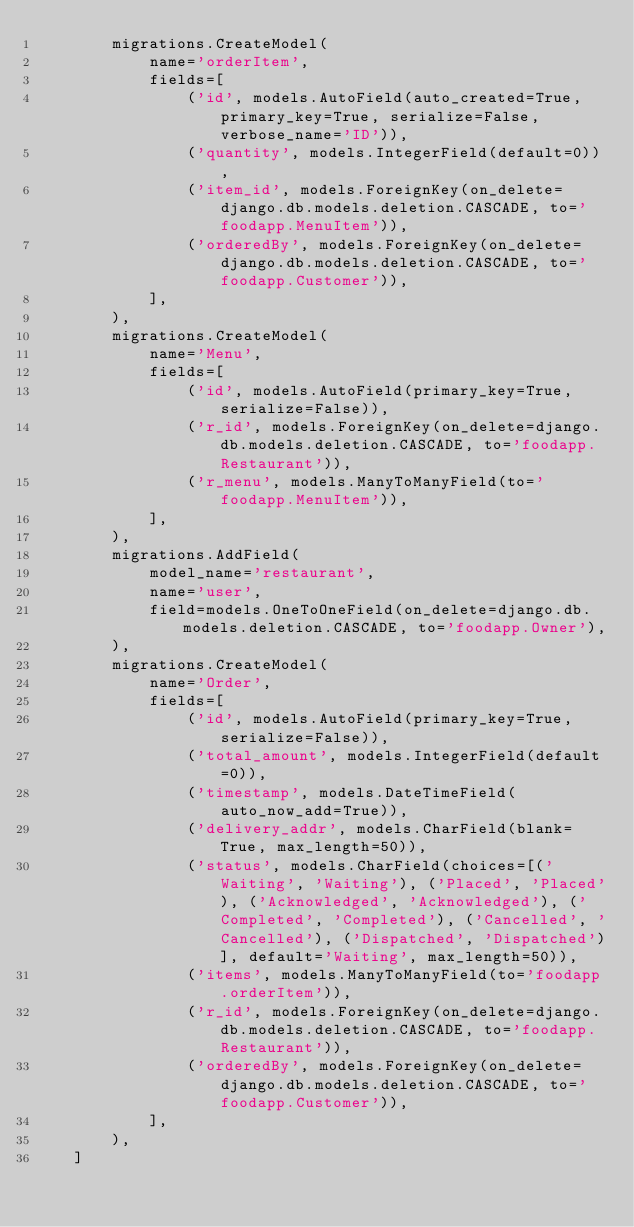<code> <loc_0><loc_0><loc_500><loc_500><_Python_>        migrations.CreateModel(
            name='orderItem',
            fields=[
                ('id', models.AutoField(auto_created=True, primary_key=True, serialize=False, verbose_name='ID')),
                ('quantity', models.IntegerField(default=0)),
                ('item_id', models.ForeignKey(on_delete=django.db.models.deletion.CASCADE, to='foodapp.MenuItem')),
                ('orderedBy', models.ForeignKey(on_delete=django.db.models.deletion.CASCADE, to='foodapp.Customer')),
            ],
        ),
        migrations.CreateModel(
            name='Menu',
            fields=[
                ('id', models.AutoField(primary_key=True, serialize=False)),
                ('r_id', models.ForeignKey(on_delete=django.db.models.deletion.CASCADE, to='foodapp.Restaurant')),
                ('r_menu', models.ManyToManyField(to='foodapp.MenuItem')),
            ],
        ),
        migrations.AddField(
            model_name='restaurant',
            name='user',
            field=models.OneToOneField(on_delete=django.db.models.deletion.CASCADE, to='foodapp.Owner'),
        ),
        migrations.CreateModel(
            name='Order',
            fields=[
                ('id', models.AutoField(primary_key=True, serialize=False)),
                ('total_amount', models.IntegerField(default=0)),
                ('timestamp', models.DateTimeField(auto_now_add=True)),
                ('delivery_addr', models.CharField(blank=True, max_length=50)),
                ('status', models.CharField(choices=[('Waiting', 'Waiting'), ('Placed', 'Placed'), ('Acknowledged', 'Acknowledged'), ('Completed', 'Completed'), ('Cancelled', 'Cancelled'), ('Dispatched', 'Dispatched')], default='Waiting', max_length=50)),
                ('items', models.ManyToManyField(to='foodapp.orderItem')),
                ('r_id', models.ForeignKey(on_delete=django.db.models.deletion.CASCADE, to='foodapp.Restaurant')),
                ('orderedBy', models.ForeignKey(on_delete=django.db.models.deletion.CASCADE, to='foodapp.Customer')),
            ],
        ),
    ]
</code> 